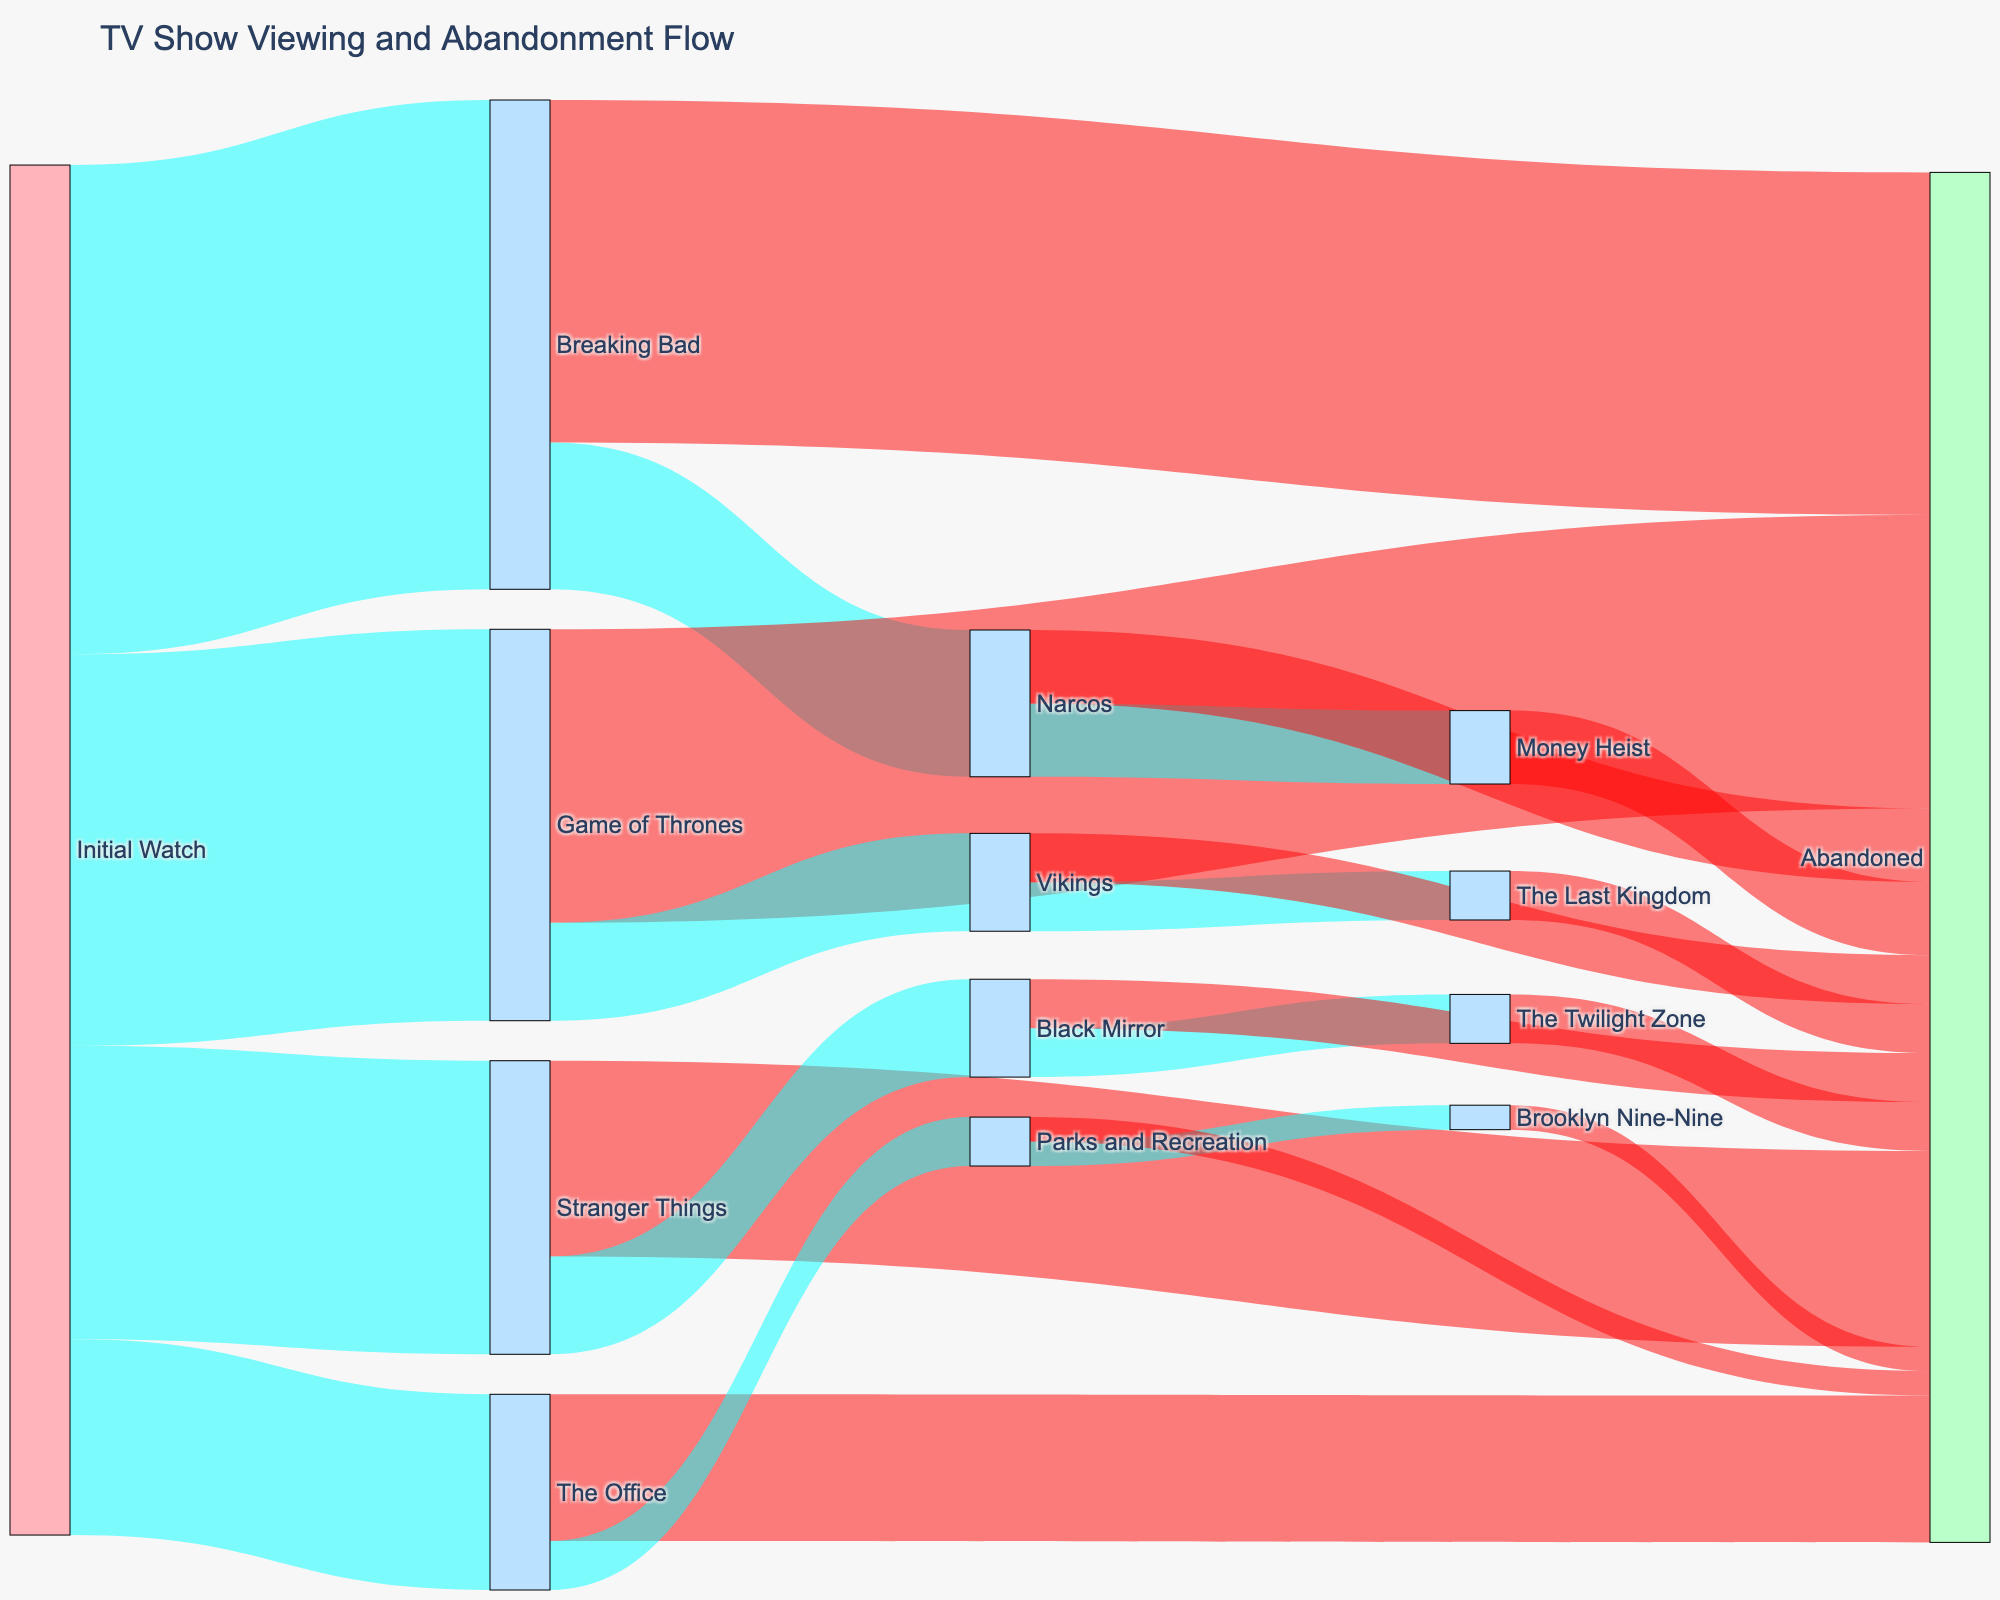What is the initial distribution of TV shows watched? View the node labeled "Initial Watch" and observe its connected links to individual TV shows. The largest flow from "Initial Watch" goes to "Breaking Bad" (100), followed by "Game of Thrones" (80), "Stranger Things" (60), and finally "The Office" (40).
Answer: Breaking Bad: 100, Game of Thrones: 80, Stranger Things: 60, The Office: 40 How many viewers abandon their initial TV show? Look for the "Abandoned" node and sum the values of incoming links directly from the initial TV shows. Breaking Bad (70), Game of Thrones (60), Stranger Things (40), and The Office (30) make up the abandoned viewers. 70 + 60 + 40 + 30 = 200.
Answer: 200 Between "Narcos" and "Vikings", which show retains more of its suggested viewers? Check the flows from "Narcos" and "Vikings" to "Abandoned". Narcos shows (15 to Abandoned) and Vikings shows (10 to Abandoned). Compare these values, smaller flow to "Abandoned" means better retention.
Answer: Narcos retains more What percentage of "Breaking Bad" viewers end up watching "Narcos"? Calculate the percentage of the flow from "Breaking Bad" to "Narcos" (30) over the total flow from "Breaking Bad" (100). So (30/100)*100 = 30%.
Answer: 30% What is the total number of viewers who end up watching "Money Heist"? "Money Heist" receives viewers from "Narcos". Look at the flow to "Money Heist," which is 15.
Answer: 15 Which show has the highest abandonment rate from its suggested viewers? Compare the flows to "Abandoned" for all the shows. Breaking Bad has the highest number of abandoning viewers (70). Having the largest flow to "Abandoned" signifies the highest abandonment rate.
Answer: Breaking Bad What is the overall trend in viewer abandonment? Note the general flow of viewers ending up in "Abandoned." Between initial and secondary viewings, many flows conclude at the "Abandoned" node, suggesting a high overall trend of abandonment.
Answer: High Abandonment What is the final fate of "Brooklyn Nine-Nine" viewers? Observe the links from "Brooklyn Nine-Nine". There is only one link to "Abandoned" with a value of 5.
Answer: Abandoned How do viewers of "The Office" transition to other shows? "The Office" has links to "Abandoned" (30) and "Parks and Recreation" (10). Summing the flows shows a majority abandoning: 30 abandon, 10 go to "Parks and Recreation."
Answer: Mostly abandon Which nodes have the highest number of interconnected flows? Count the number of link connections for each node. "Initial Watch" and "Abandoned" nodes have the most interconnected flows. This can be determined by visually spotting the thickest and most numerous connections.
Answer: Initial Watch and Abandoned 